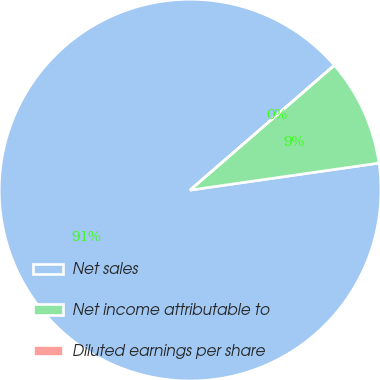<chart> <loc_0><loc_0><loc_500><loc_500><pie_chart><fcel>Net sales<fcel>Net income attributable to<fcel>Diluted earnings per share<nl><fcel>90.91%<fcel>9.09%<fcel>0.0%<nl></chart> 